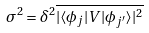<formula> <loc_0><loc_0><loc_500><loc_500>\sigma ^ { 2 } = \delta ^ { 2 } \overline { | \langle \phi _ { j } | V | \phi _ { j ^ { \prime } } \rangle | ^ { 2 } }</formula> 